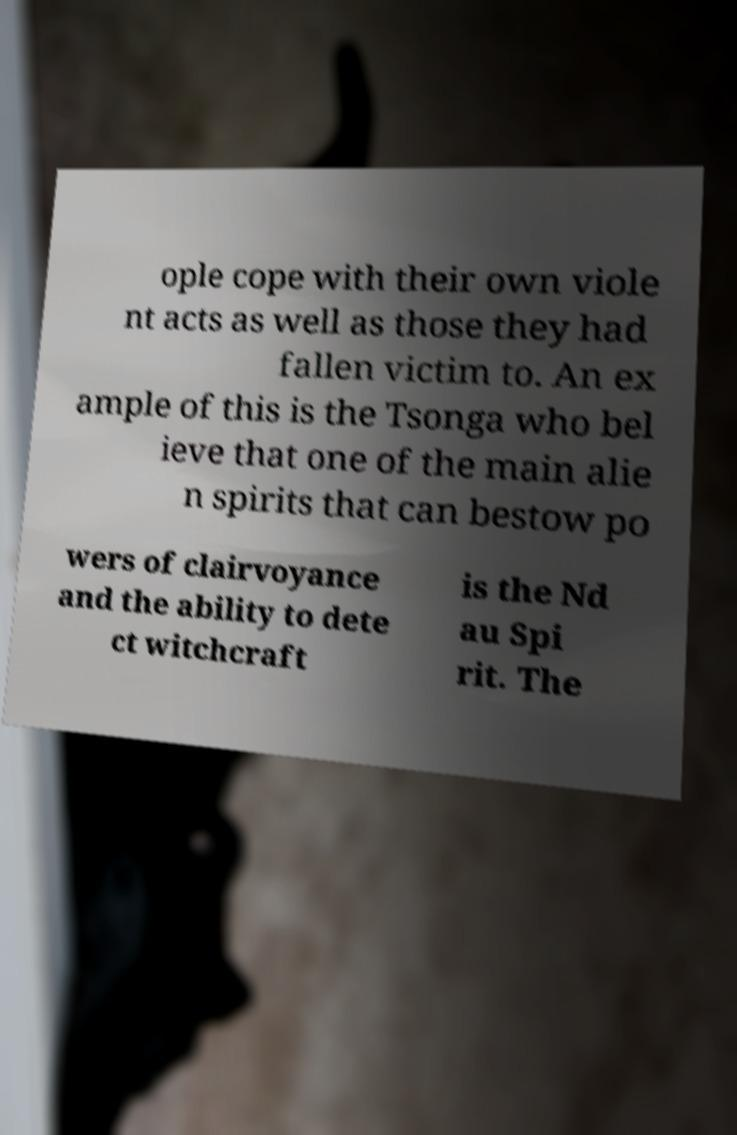Could you assist in decoding the text presented in this image and type it out clearly? ople cope with their own viole nt acts as well as those they had fallen victim to. An ex ample of this is the Tsonga who bel ieve that one of the main alie n spirits that can bestow po wers of clairvoyance and the ability to dete ct witchcraft is the Nd au Spi rit. The 